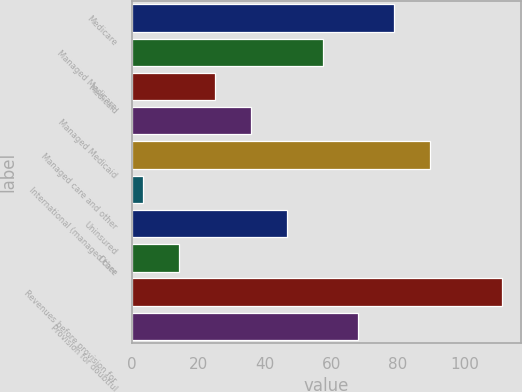<chart> <loc_0><loc_0><loc_500><loc_500><bar_chart><fcel>Medicare<fcel>Managed Medicare<fcel>Medicaid<fcel>Managed Medicaid<fcel>Managed care and other<fcel>International (managed care<fcel>Uninsured<fcel>Other<fcel>Revenues before provision for<fcel>Provision for doubtful<nl><fcel>78.93<fcel>57.35<fcel>24.98<fcel>35.77<fcel>89.72<fcel>3.4<fcel>46.56<fcel>14.19<fcel>111.3<fcel>68.14<nl></chart> 